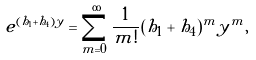<formula> <loc_0><loc_0><loc_500><loc_500>e ^ { ( h _ { 1 } + h _ { 4 } ) y } = \sum _ { m = 0 } ^ { \infty } \frac { 1 } { m ! } ( h _ { 1 } + h _ { 4 } ) ^ { m } y ^ { m } ,</formula> 